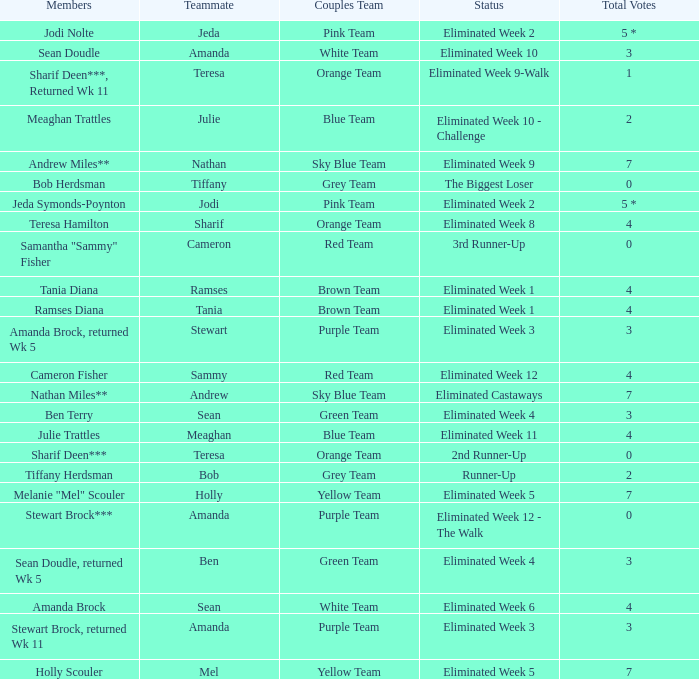What was Holly Scouler's total votes 7.0. 